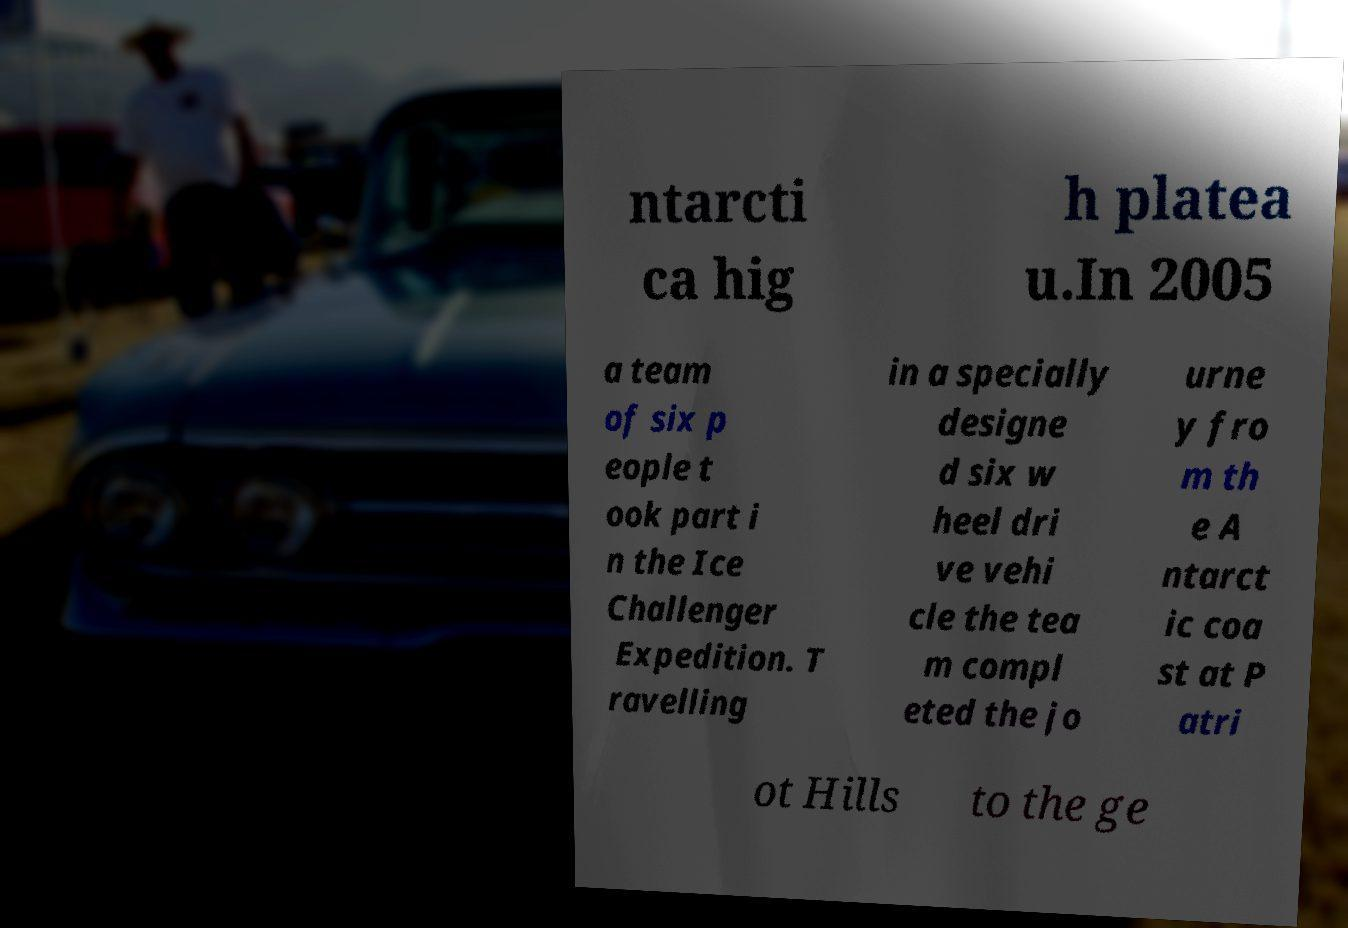What messages or text are displayed in this image? I need them in a readable, typed format. ntarcti ca hig h platea u.In 2005 a team of six p eople t ook part i n the Ice Challenger Expedition. T ravelling in a specially designe d six w heel dri ve vehi cle the tea m compl eted the jo urne y fro m th e A ntarct ic coa st at P atri ot Hills to the ge 